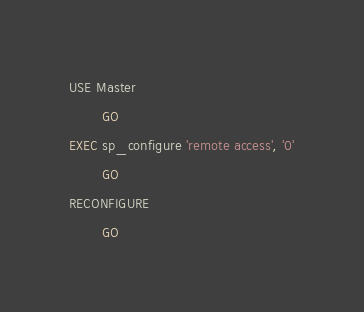Convert code to text. <code><loc_0><loc_0><loc_500><loc_500><_SQL_>USE Master
        GO
EXEC sp_configure 'remote access', '0'
        GO
RECONFIGURE
        GO</code> 